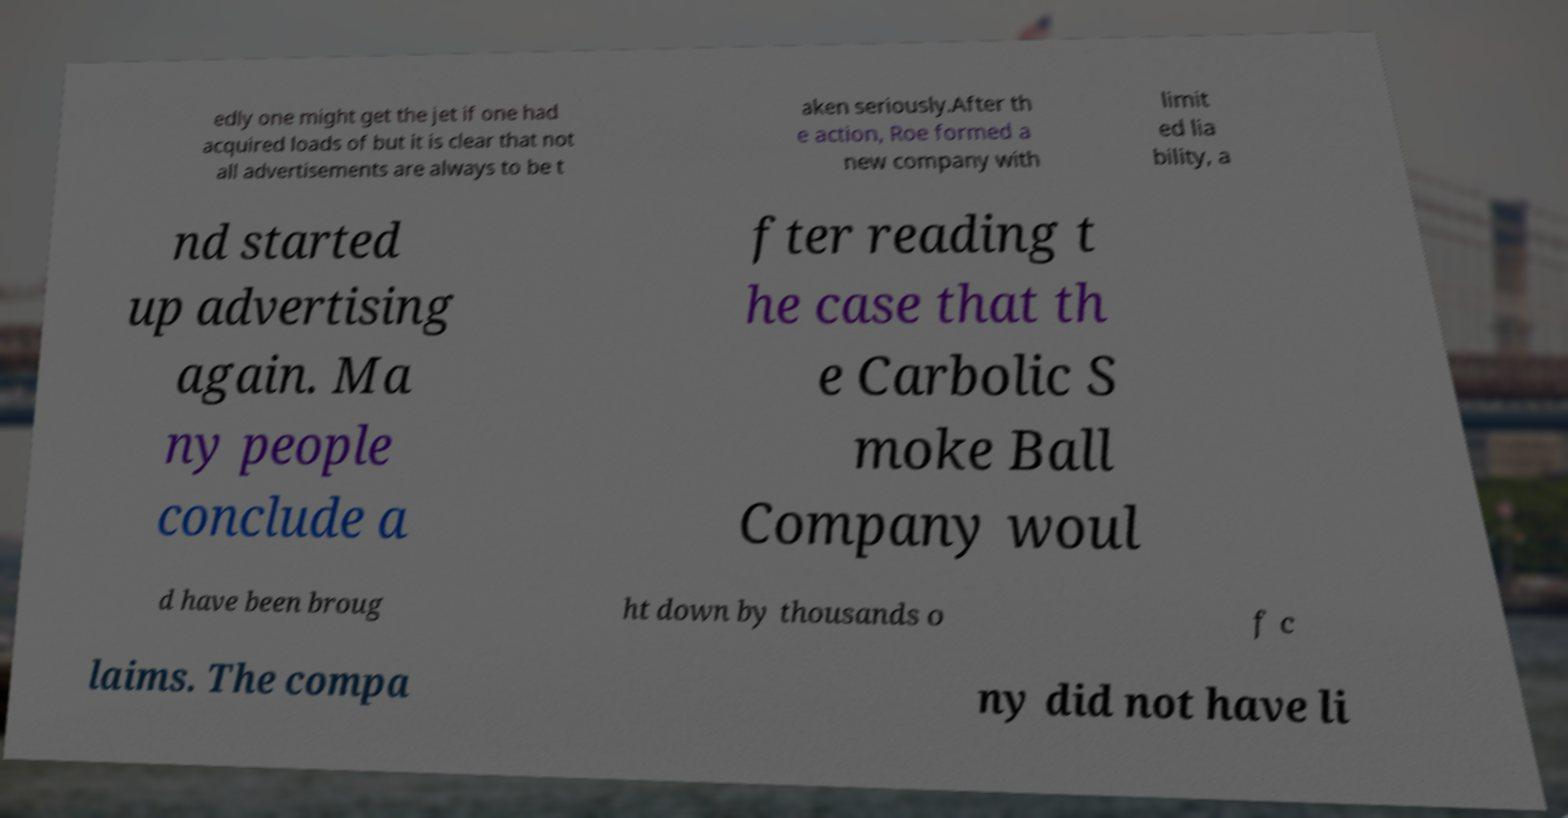What messages or text are displayed in this image? I need them in a readable, typed format. edly one might get the jet if one had acquired loads of but it is clear that not all advertisements are always to be t aken seriously.After th e action, Roe formed a new company with limit ed lia bility, a nd started up advertising again. Ma ny people conclude a fter reading t he case that th e Carbolic S moke Ball Company woul d have been broug ht down by thousands o f c laims. The compa ny did not have li 